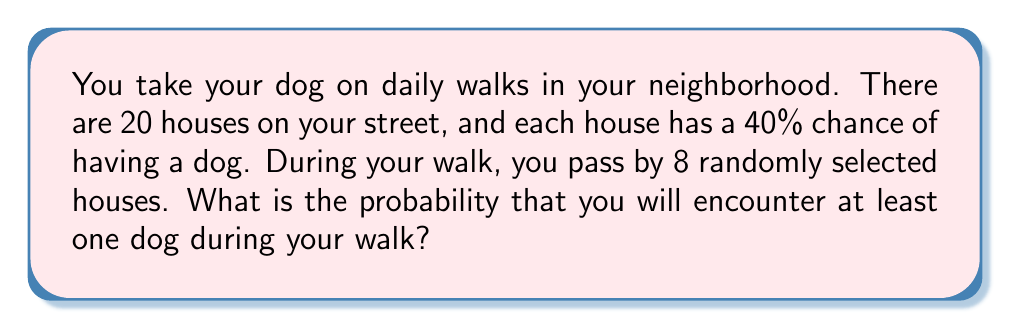What is the answer to this math problem? Let's approach this step-by-step:

1) First, let's calculate the probability of not encountering a dog at a single house:
   $P(\text{no dog}) = 1 - P(\text{dog}) = 1 - 0.4 = 0.6$

2) Now, for your walk to have no dog encounters, all 8 houses you pass must not have a dog out. The probability of this is:
   $P(\text{no dogs in 8 houses}) = 0.6^8$

3) Let's calculate this:
   $0.6^8 \approx 0.0168$

4) Therefore, the probability of encountering at least one dog is the complement of this probability:
   $P(\text{at least one dog}) = 1 - P(\text{no dogs in 8 houses})$
   $= 1 - 0.6^8$
   $\approx 1 - 0.0168$
   $\approx 0.9832$

5) Converting to a percentage:
   $0.9832 \times 100\% = 98.32\%$
Answer: 98.32% 